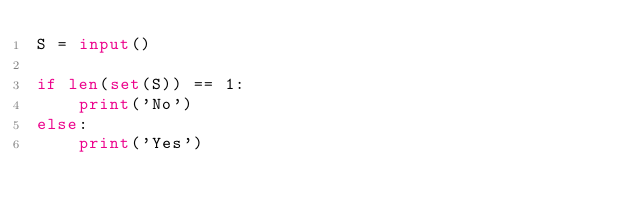<code> <loc_0><loc_0><loc_500><loc_500><_Python_>S = input()

if len(set(S)) == 1:
    print('No')
else:
    print('Yes')</code> 